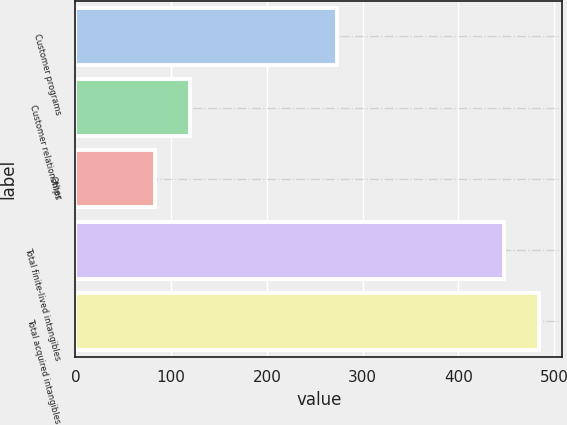Convert chart to OTSL. <chart><loc_0><loc_0><loc_500><loc_500><bar_chart><fcel>Customer programs<fcel>Customer relationships<fcel>Other<fcel>Total finite-lived intangibles<fcel>Total acquired intangibles<nl><fcel>273<fcel>119.5<fcel>83<fcel>448<fcel>484.5<nl></chart> 